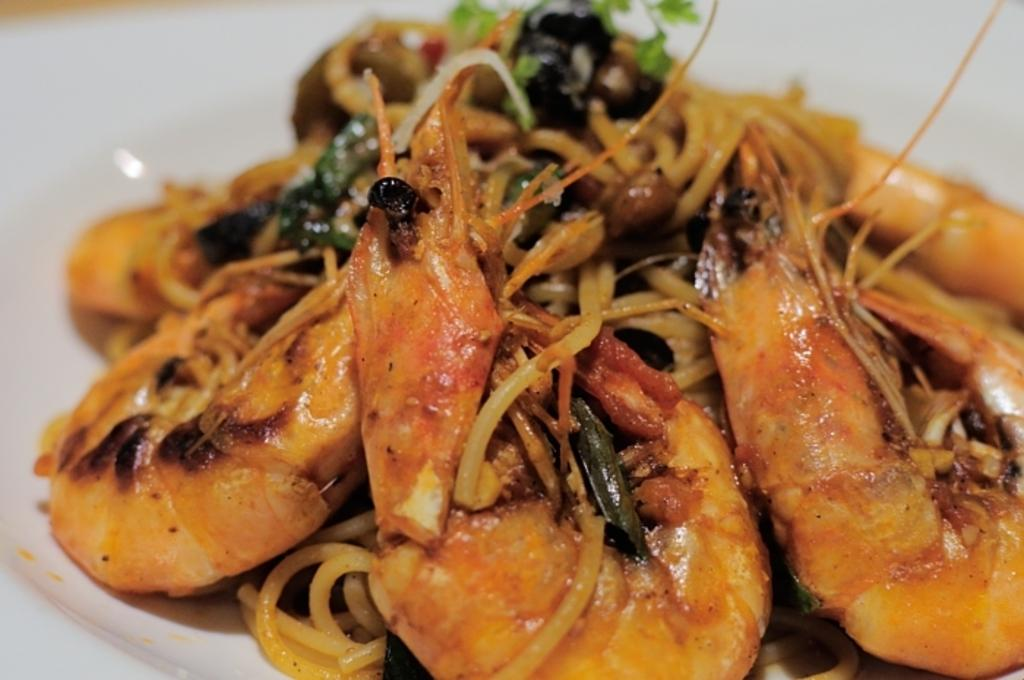What is present on the plate in the image? Unfortunately, the provided facts do not specify what is on the plate. However, we can confirm that there is a plate in the image. How many fingers can be seen on the goat in the image? There is no goat present in the image, so it is not possible to determine how many fingers it might have. 